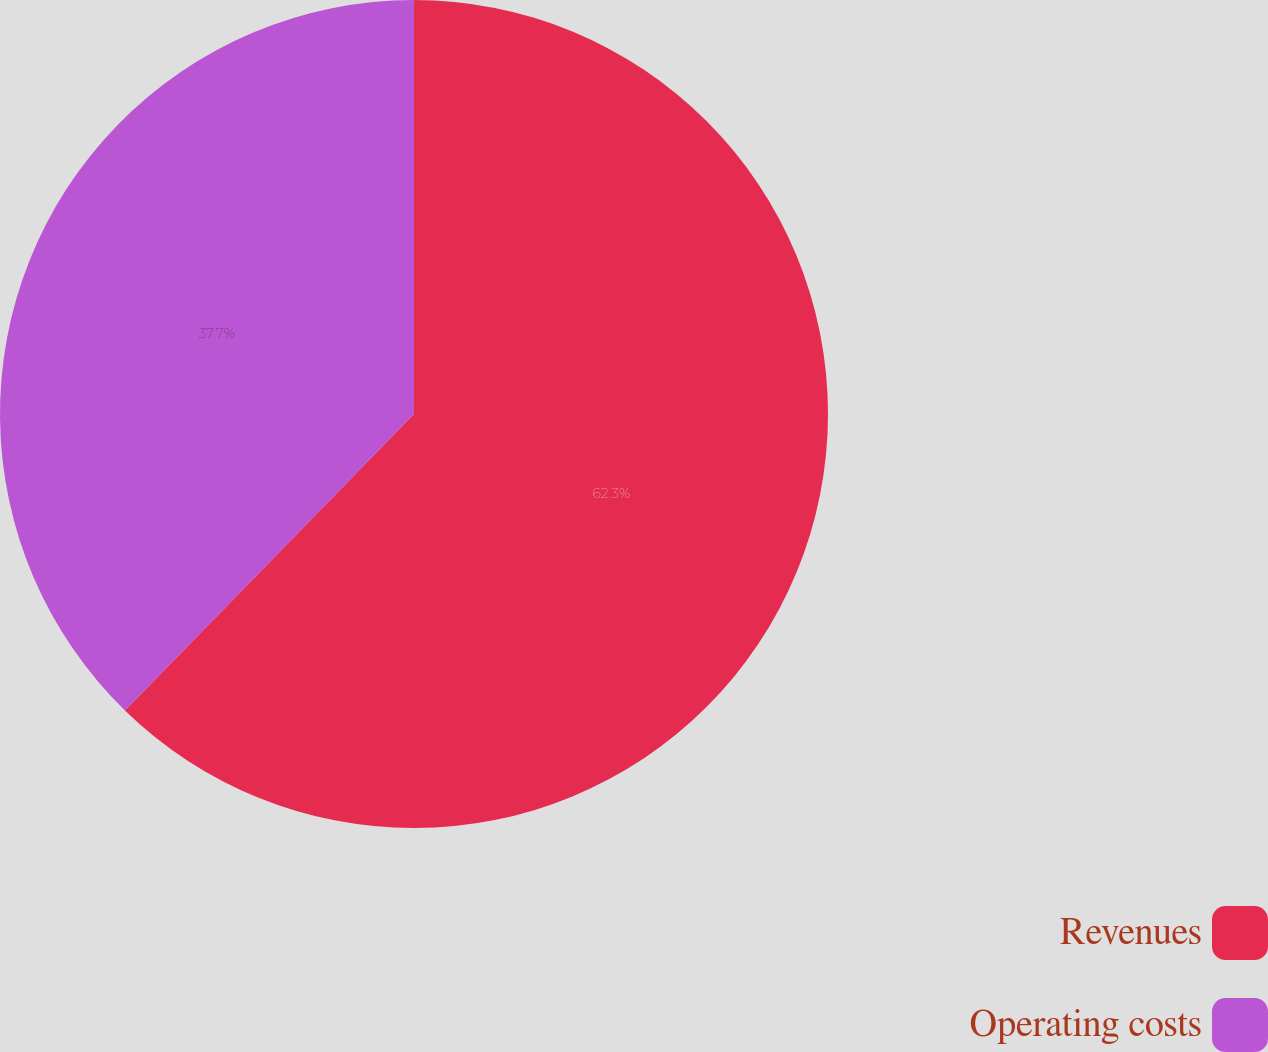<chart> <loc_0><loc_0><loc_500><loc_500><pie_chart><fcel>Revenues<fcel>Operating costs<nl><fcel>62.3%<fcel>37.7%<nl></chart> 